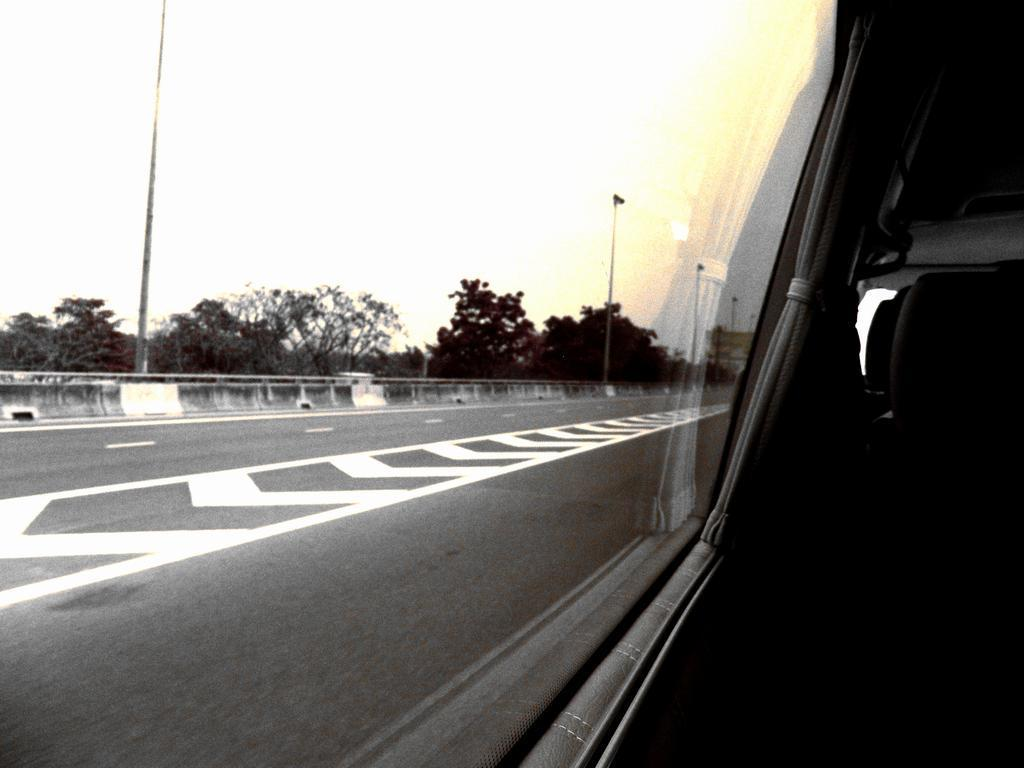What can be seen on the right side of the image? There are seats in a car on the right side of the image. What is on the left side of the image? There is a road on the left side of the image. What is visible in the background of the image? There are poles, railing, trees, and the sky visible in the background of the image. What type of balance is being demonstrated by the building in the image? There is no building present in the image; it features a car and various background elements. What is the name of the thing that is being balanced in the image? There is no specific "thing" being balanced in the image. 